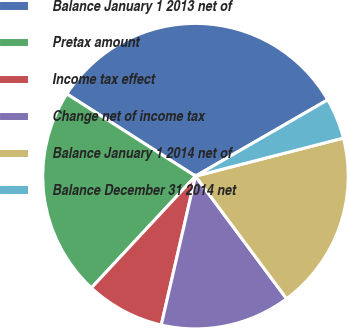Convert chart to OTSL. <chart><loc_0><loc_0><loc_500><loc_500><pie_chart><fcel>Balance January 1 2013 net of<fcel>Pretax amount<fcel>Income tax effect<fcel>Change net of income tax<fcel>Balance January 1 2014 net of<fcel>Balance December 31 2014 net<nl><fcel>32.62%<fcel>22.11%<fcel>8.34%<fcel>13.77%<fcel>18.84%<fcel>4.32%<nl></chart> 